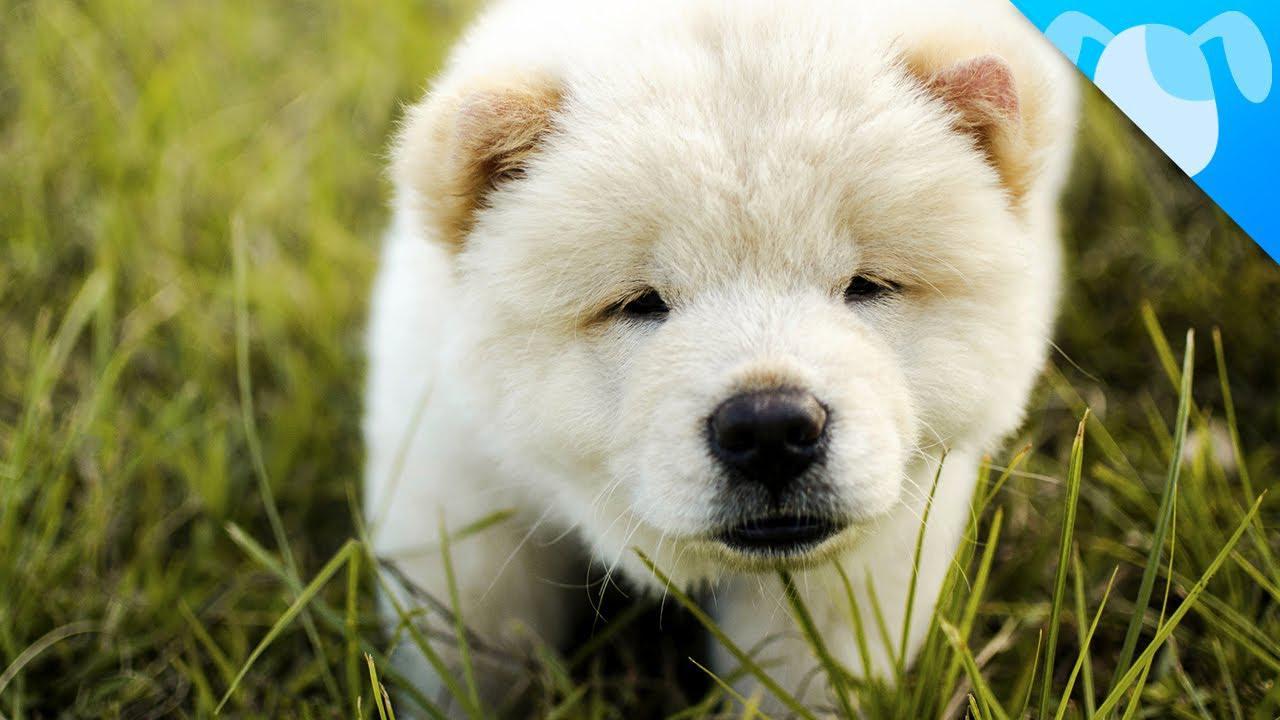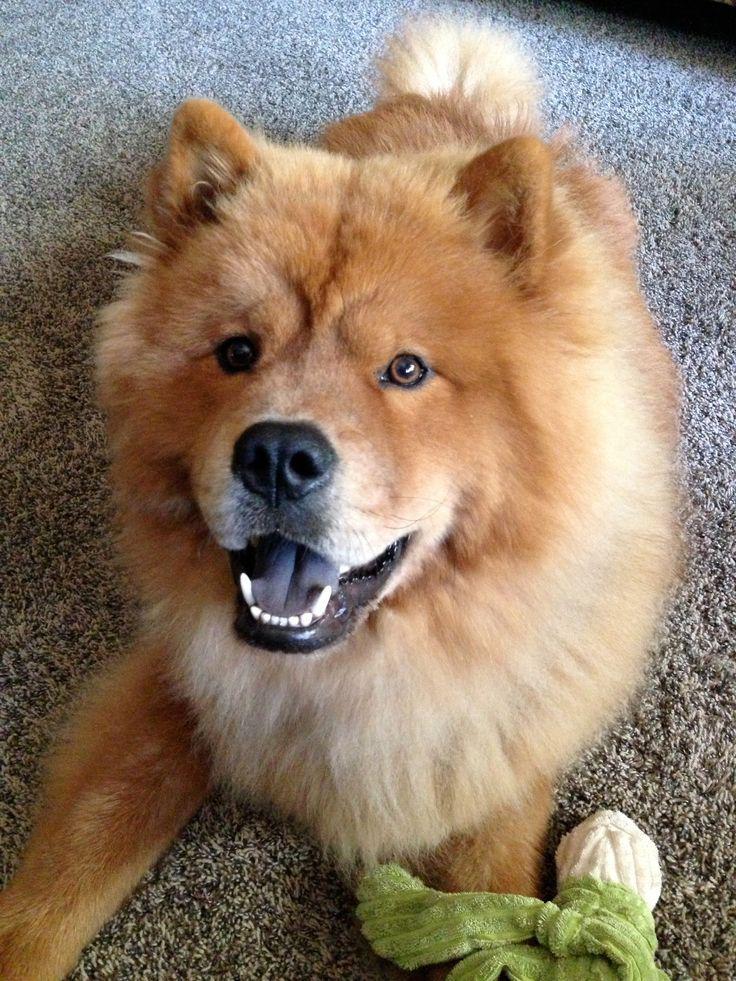The first image is the image on the left, the second image is the image on the right. Considering the images on both sides, is "Each image shows a chow dog standing on grass, and one image shows a dog standing with its body turned leftward." valid? Answer yes or no. No. The first image is the image on the left, the second image is the image on the right. Given the left and right images, does the statement "Two dogs are standing." hold true? Answer yes or no. No. 